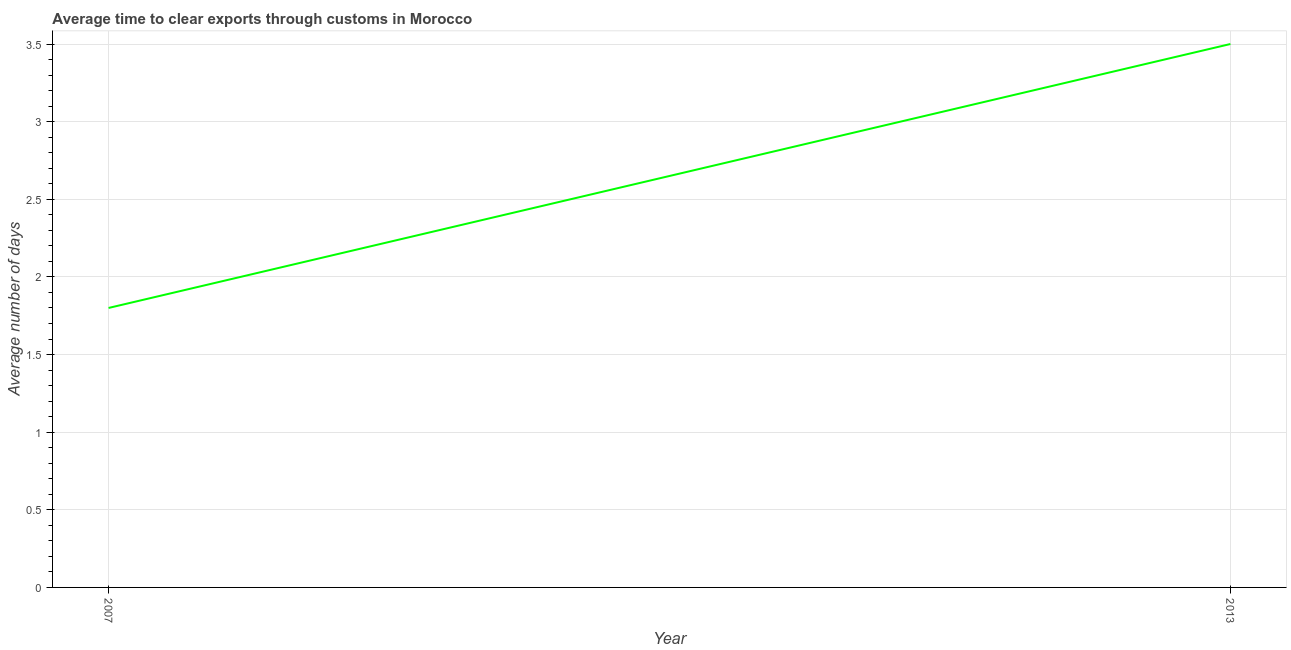Across all years, what is the maximum time to clear exports through customs?
Offer a very short reply. 3.5. Across all years, what is the minimum time to clear exports through customs?
Give a very brief answer. 1.8. What is the average time to clear exports through customs per year?
Keep it short and to the point. 2.65. What is the median time to clear exports through customs?
Offer a very short reply. 2.65. What is the ratio of the time to clear exports through customs in 2007 to that in 2013?
Provide a short and direct response. 0.51. Does the time to clear exports through customs monotonically increase over the years?
Your answer should be compact. Yes. What is the difference between two consecutive major ticks on the Y-axis?
Give a very brief answer. 0.5. What is the title of the graph?
Give a very brief answer. Average time to clear exports through customs in Morocco. What is the label or title of the Y-axis?
Ensure brevity in your answer.  Average number of days. What is the difference between the Average number of days in 2007 and 2013?
Ensure brevity in your answer.  -1.7. What is the ratio of the Average number of days in 2007 to that in 2013?
Offer a very short reply. 0.51. 